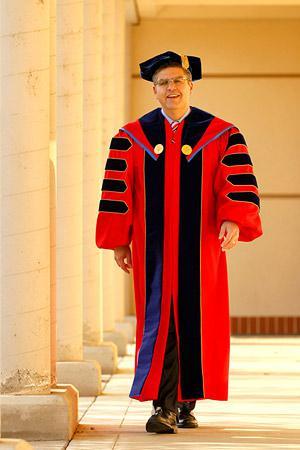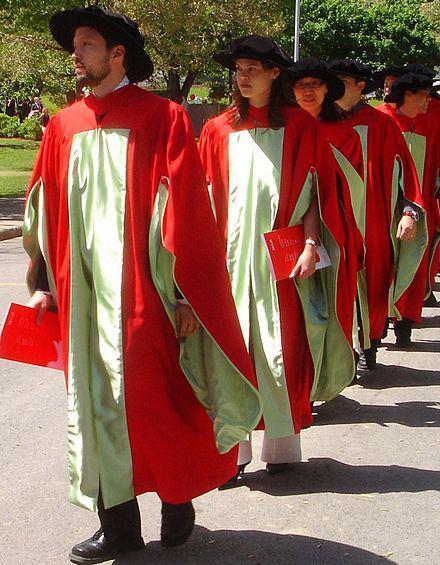The first image is the image on the left, the second image is the image on the right. Considering the images on both sides, is "One of the graduates is standing at a podium." valid? Answer yes or no. No. The first image is the image on the left, the second image is the image on the right. Analyze the images presented: Is the assertion "There is a man in the left image standing at a lectern." valid? Answer yes or no. No. 